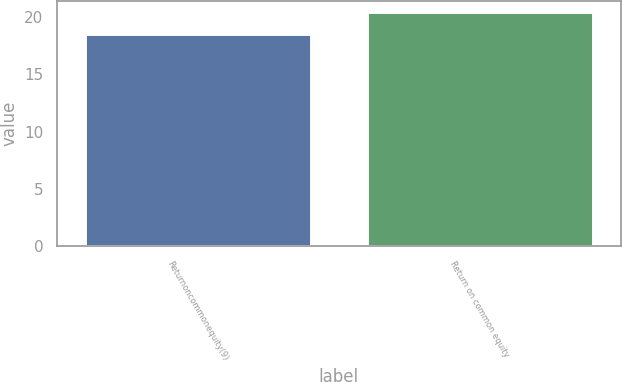Convert chart to OTSL. <chart><loc_0><loc_0><loc_500><loc_500><bar_chart><fcel>Returnoncommonequity(9)<fcel>Return on common equity<nl><fcel>18.5<fcel>20.4<nl></chart> 